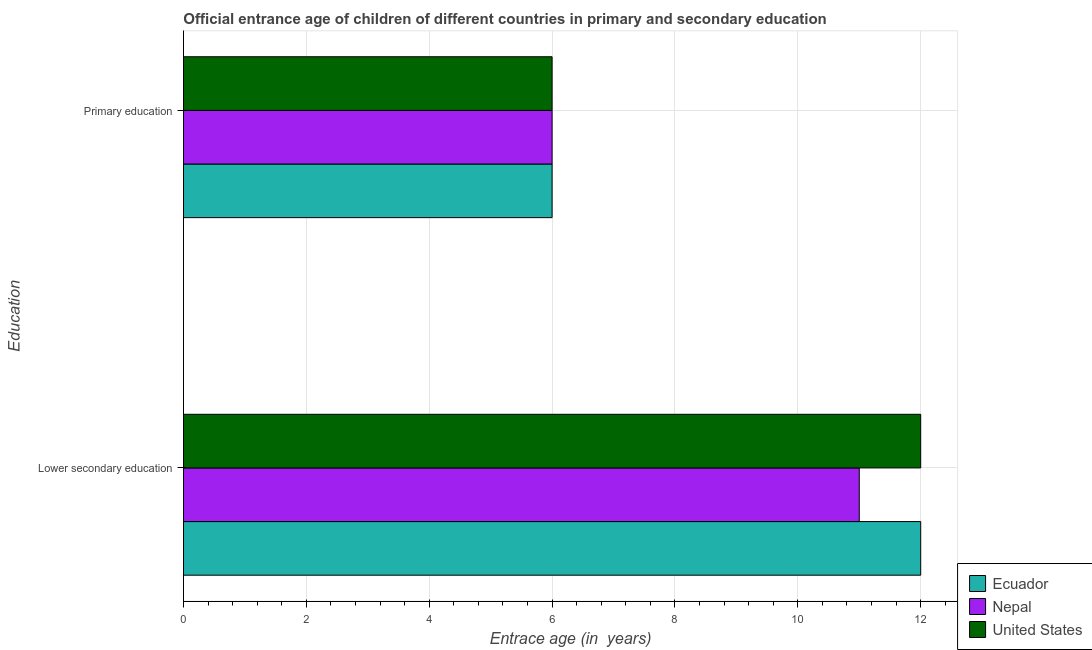How many bars are there on the 1st tick from the top?
Provide a succinct answer. 3. What is the label of the 2nd group of bars from the top?
Offer a very short reply. Lower secondary education. What is the entrance age of children in lower secondary education in Nepal?
Make the answer very short. 11. Across all countries, what is the maximum entrance age of children in lower secondary education?
Give a very brief answer. 12. Across all countries, what is the minimum entrance age of chiildren in primary education?
Your answer should be very brief. 6. In which country was the entrance age of children in lower secondary education maximum?
Offer a very short reply. Ecuador. In which country was the entrance age of children in lower secondary education minimum?
Ensure brevity in your answer.  Nepal. What is the total entrance age of children in lower secondary education in the graph?
Provide a succinct answer. 35. What is the difference between the entrance age of children in lower secondary education in Ecuador and that in United States?
Ensure brevity in your answer.  0. What is the difference between the entrance age of chiildren in primary education in Ecuador and the entrance age of children in lower secondary education in United States?
Provide a succinct answer. -6. What is the average entrance age of children in lower secondary education per country?
Ensure brevity in your answer.  11.67. What is the difference between the entrance age of chiildren in primary education and entrance age of children in lower secondary education in United States?
Offer a very short reply. -6. In how many countries, is the entrance age of chiildren in primary education greater than 9.6 years?
Your response must be concise. 0. What is the ratio of the entrance age of children in lower secondary education in Nepal to that in United States?
Ensure brevity in your answer.  0.92. Is the entrance age of children in lower secondary education in United States less than that in Ecuador?
Provide a succinct answer. No. What does the 2nd bar from the top in Primary education represents?
Your response must be concise. Nepal. Are all the bars in the graph horizontal?
Offer a terse response. Yes. How many countries are there in the graph?
Ensure brevity in your answer.  3. What is the difference between two consecutive major ticks on the X-axis?
Your answer should be very brief. 2. Does the graph contain any zero values?
Your answer should be compact. No. How many legend labels are there?
Make the answer very short. 3. How are the legend labels stacked?
Provide a short and direct response. Vertical. What is the title of the graph?
Your response must be concise. Official entrance age of children of different countries in primary and secondary education. Does "Turkmenistan" appear as one of the legend labels in the graph?
Offer a very short reply. No. What is the label or title of the X-axis?
Make the answer very short. Entrace age (in  years). What is the label or title of the Y-axis?
Offer a very short reply. Education. What is the Entrace age (in  years) of Ecuador in Lower secondary education?
Make the answer very short. 12. What is the Entrace age (in  years) in Nepal in Lower secondary education?
Give a very brief answer. 11. What is the Entrace age (in  years) of Nepal in Primary education?
Keep it short and to the point. 6. What is the Entrace age (in  years) of United States in Primary education?
Provide a short and direct response. 6. Across all Education, what is the maximum Entrace age (in  years) of Ecuador?
Keep it short and to the point. 12. Across all Education, what is the maximum Entrace age (in  years) in United States?
Provide a short and direct response. 12. Across all Education, what is the minimum Entrace age (in  years) in Nepal?
Offer a very short reply. 6. Across all Education, what is the minimum Entrace age (in  years) in United States?
Your response must be concise. 6. What is the total Entrace age (in  years) of Ecuador in the graph?
Ensure brevity in your answer.  18. What is the difference between the Entrace age (in  years) in United States in Lower secondary education and that in Primary education?
Offer a terse response. 6. What is the difference between the Entrace age (in  years) in Ecuador in Lower secondary education and the Entrace age (in  years) in United States in Primary education?
Offer a terse response. 6. What is the average Entrace age (in  years) in Nepal per Education?
Give a very brief answer. 8.5. What is the average Entrace age (in  years) in United States per Education?
Ensure brevity in your answer.  9. What is the difference between the Entrace age (in  years) in Ecuador and Entrace age (in  years) in United States in Lower secondary education?
Your answer should be compact. 0. What is the difference between the Entrace age (in  years) of Nepal and Entrace age (in  years) of United States in Lower secondary education?
Offer a very short reply. -1. What is the difference between the Entrace age (in  years) of Ecuador and Entrace age (in  years) of Nepal in Primary education?
Your answer should be compact. 0. What is the difference between the Entrace age (in  years) of Ecuador and Entrace age (in  years) of United States in Primary education?
Offer a terse response. 0. What is the ratio of the Entrace age (in  years) in Ecuador in Lower secondary education to that in Primary education?
Ensure brevity in your answer.  2. What is the ratio of the Entrace age (in  years) of Nepal in Lower secondary education to that in Primary education?
Your answer should be compact. 1.83. What is the difference between the highest and the second highest Entrace age (in  years) of Ecuador?
Make the answer very short. 6. What is the difference between the highest and the second highest Entrace age (in  years) in Nepal?
Make the answer very short. 5. What is the difference between the highest and the second highest Entrace age (in  years) in United States?
Provide a short and direct response. 6. What is the difference between the highest and the lowest Entrace age (in  years) in Ecuador?
Your answer should be very brief. 6. What is the difference between the highest and the lowest Entrace age (in  years) in United States?
Keep it short and to the point. 6. 